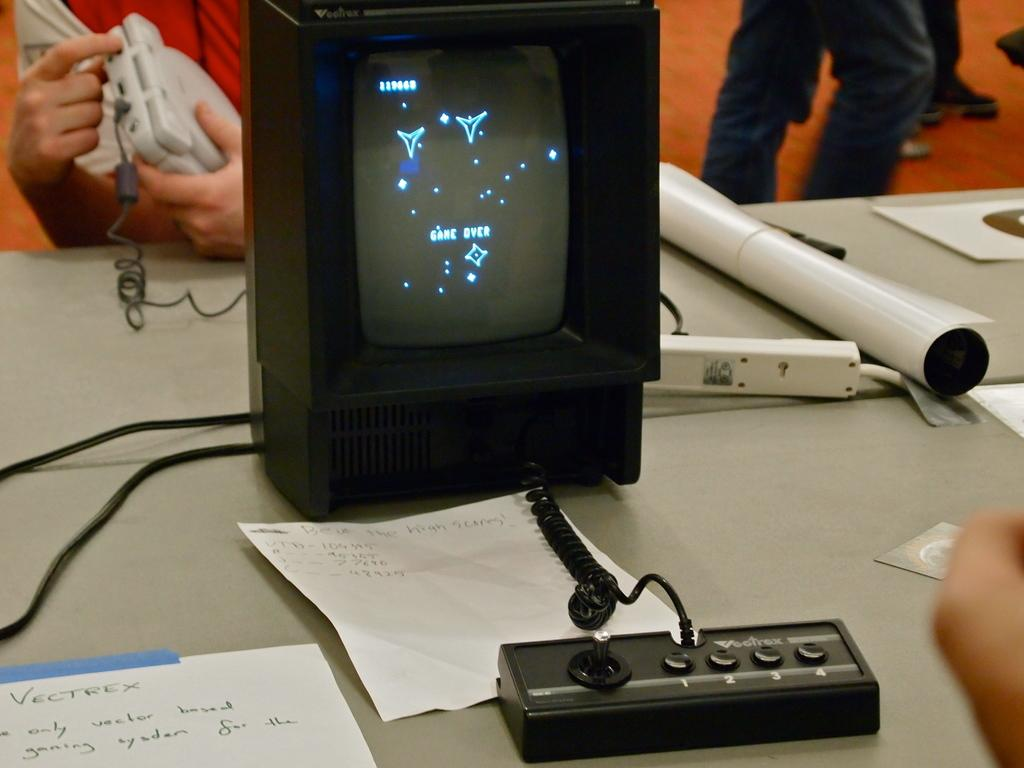What type of furniture is visible in the image? There is a table in the image. What can be seen on top of the table? Electrical devices are present on the table. Are there any people in the image? Yes, there are people standing behind the table. What is one person doing with an electrical device? A person is holding an electrical device in their hand. How does the person on the bike in the image feel about the exchange of electrical devices? There is no bike or exchange of electrical devices present in the image. 